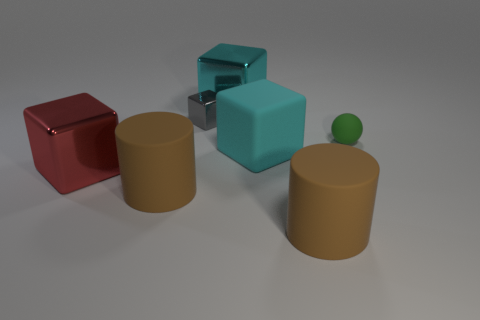What number of other things are there of the same shape as the large cyan matte object?
Ensure brevity in your answer.  3. What number of cyan objects are cubes or spheres?
Make the answer very short. 2. What is the color of the tiny thing that is made of the same material as the big red thing?
Provide a short and direct response. Gray. Do the big brown cylinder on the left side of the rubber cube and the large cylinder to the right of the large matte cube have the same material?
Offer a very short reply. Yes. What size is the metallic object that is the same color as the rubber block?
Ensure brevity in your answer.  Large. There is a big block behind the green ball; what material is it?
Offer a very short reply. Metal. There is a big cyan thing in front of the green sphere; is it the same shape as the big brown rubber object on the right side of the small block?
Offer a terse response. No. Are there any large rubber things?
Your answer should be very brief. Yes. There is another large cyan thing that is the same shape as the big cyan metal thing; what is it made of?
Offer a very short reply. Rubber. Are there any cyan matte objects to the left of the ball?
Your answer should be compact. Yes. 